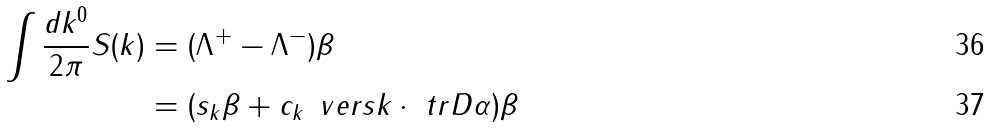Convert formula to latex. <formula><loc_0><loc_0><loc_500><loc_500>\int \frac { d k ^ { 0 } } { 2 \pi } S ( k ) & = ( \Lambda ^ { + } - \Lambda ^ { - } ) \beta \\ & = ( s _ { k } \beta + c _ { k } \, \ v e r s { k } \cdot \ t r D { \alpha } ) \beta</formula> 